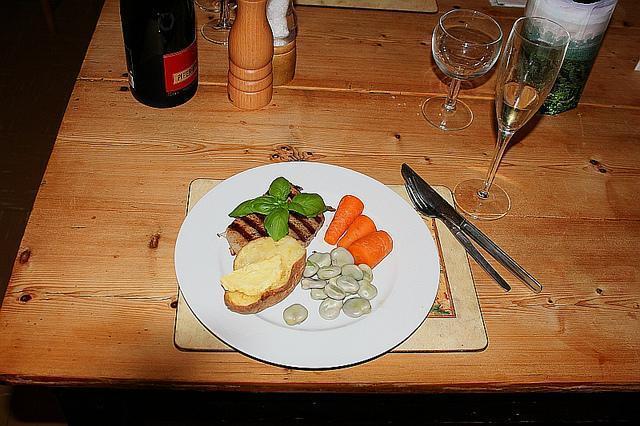How many knives are depicted?
Give a very brief answer. 1. How many bottles are visible?
Give a very brief answer. 2. How many wine glasses are visible?
Give a very brief answer. 2. How many dining tables are there?
Give a very brief answer. 1. 